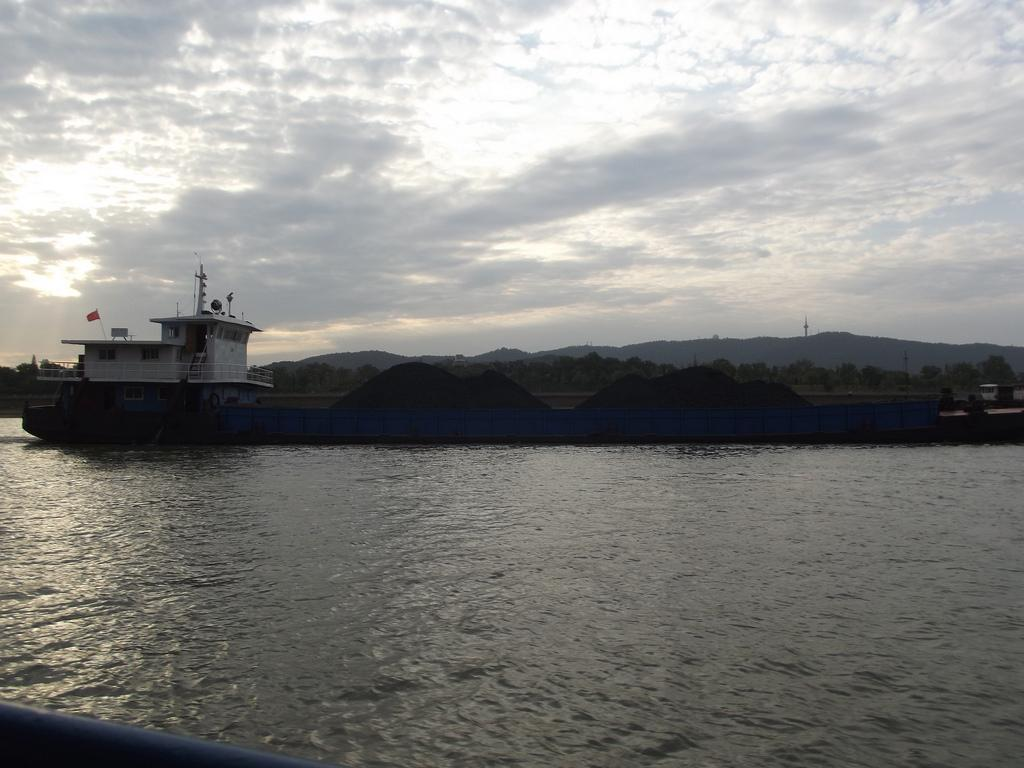What is the main subject of the image? The main subject of the image is a ship in the water. What can be seen on the ship? The ship has a flag and railings. What is visible in the background of the image? There are mountains and the sky in the background of the image. What type of fruit is hanging from the ship's railings in the image? There is no fruit hanging from the ship's railings in the image. What question is being asked by the ship's captain in the image? There is no indication of a question being asked by the ship's captain in the image. 